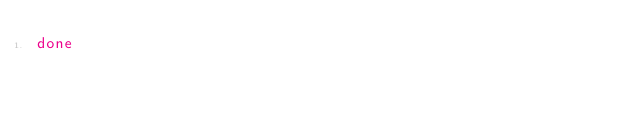<code> <loc_0><loc_0><loc_500><loc_500><_Bash_>done
</code> 